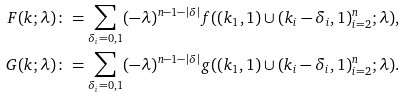Convert formula to latex. <formula><loc_0><loc_0><loc_500><loc_500>F ( k ; \lambda ) & \colon = \sum _ { \delta _ { i } = 0 , 1 } ( - \lambda ) ^ { n - 1 - | \delta | } f ( ( k _ { 1 } , 1 ) \cup ( k _ { i } - \delta _ { i } , 1 ) _ { i = 2 } ^ { n } ; \lambda ) , \\ G ( k ; \lambda ) & \colon = \sum _ { \delta _ { i } = 0 , 1 } ( - \lambda ) ^ { n - 1 - | \delta | } g ( ( k _ { 1 } , 1 ) \cup ( k _ { i } - \delta _ { i } , 1 ) _ { i = 2 } ^ { n } ; \lambda ) .</formula> 